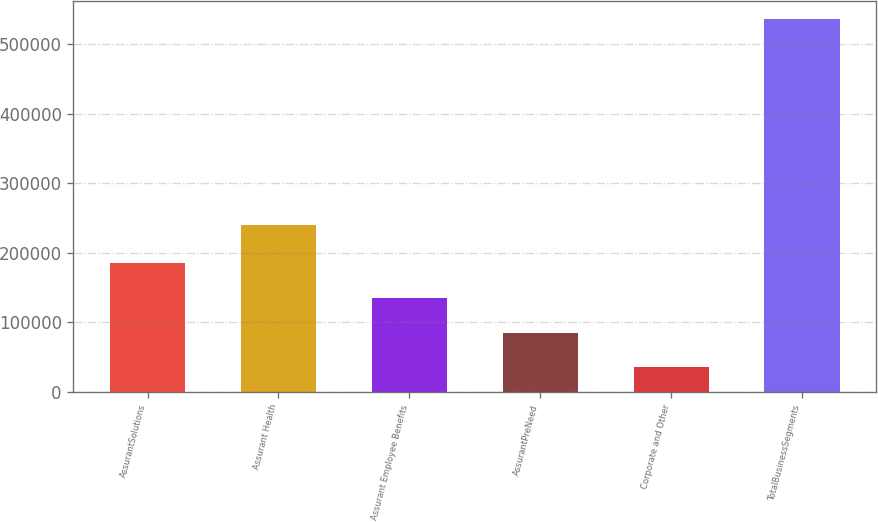Convert chart. <chart><loc_0><loc_0><loc_500><loc_500><bar_chart><fcel>AssurantSolutions<fcel>Assurant Health<fcel>Assurant Employee Benefits<fcel>AssurantPreNeed<fcel>Corporate and Other<fcel>TotalBusinessSegments<nl><fcel>185317<fcel>240218<fcel>135230<fcel>85142.3<fcel>35055<fcel>535928<nl></chart> 